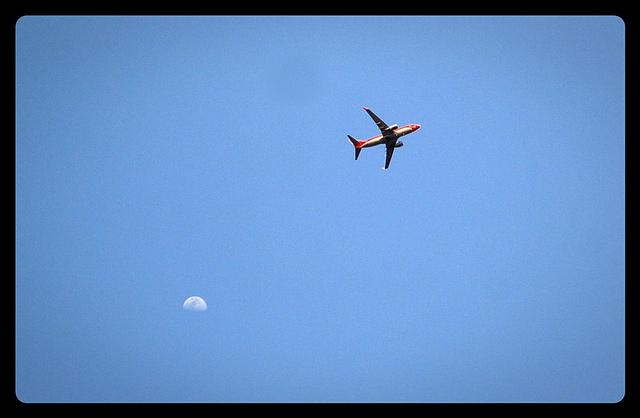Are there trees in this scene?
Short answer required. No. Is this 4 different pictures?
Give a very brief answer. No. Is this picture in color?
Be succinct. Yes. Overcast or sunny?
Give a very brief answer. Sunny. Is there a plane in the sky?
Quick response, please. Yes. Does the moon appear to be an waning crescent?
Quick response, please. Yes. What color is the plane?
Short answer required. Red. Has the sun set?
Answer briefly. No. Could this be a valve?
Write a very short answer. No. What are these items?
Write a very short answer. Plane and moon. Is the plane in motion?
Give a very brief answer. Yes. Are there clouds?
Quick response, please. No. Do the people in the plane think the photographer looks like an ant?
Answer briefly. Yes. What directions are the planes headed?
Give a very brief answer. Right. What is the weather like?
Write a very short answer. Clear. What is behind the planes?
Quick response, please. Moon. Is it cloudy?
Answer briefly. No. Are there clouds in the sky?
Write a very short answer. No. What color is the photo?
Give a very brief answer. Blue. 